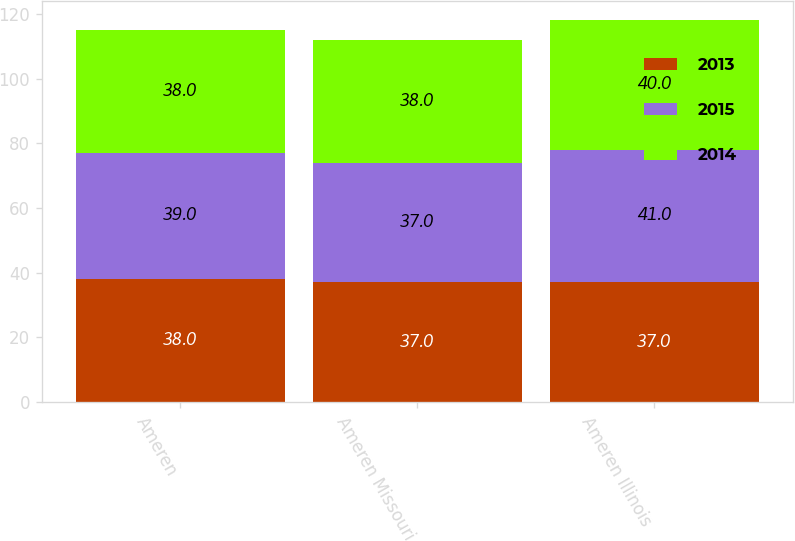Convert chart. <chart><loc_0><loc_0><loc_500><loc_500><stacked_bar_chart><ecel><fcel>Ameren<fcel>Ameren Missouri<fcel>Ameren Illinois<nl><fcel>2013<fcel>38<fcel>37<fcel>37<nl><fcel>2015<fcel>39<fcel>37<fcel>41<nl><fcel>2014<fcel>38<fcel>38<fcel>40<nl></chart> 